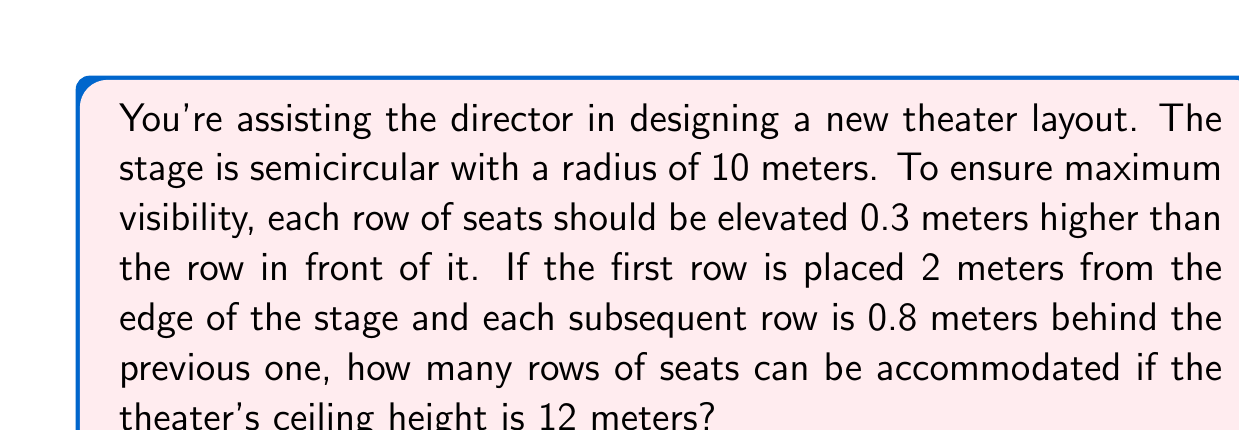Help me with this question. Let's approach this step-by-step:

1) First, we need to determine the height of the first row relative to the stage:
   Let's assume the stage is at ground level (0 meters).
   The first row will be at the same level as the stage.

2) Now, let's set up a formula for the height of each row:
   $h_n = 0.3(n-1)$, where $n$ is the row number (starting from 1)

3) We also need a formula for the distance of each row from the stage edge:
   $d_n = 2 + 0.8(n-1)$

4) The maximum number of rows will be reached when the height of a row equals or just exceeds the ceiling height (12 meters).

5) We can set up an inequality:
   $0.3(n-1) \leq 12$

6) Solving for n:
   $0.3n - 0.3 \leq 12$
   $0.3n \leq 12.3$
   $n \leq 41$

7) The largest integer value of n that satisfies this inequality is 41.

8) Let's verify:
   Height of the 41st row: $h_{41} = 0.3(41-1) = 12$ meters
   Distance of the 41st row: $d_{41} = 2 + 0.8(41-1) = 34$ meters

9) The 41st row exactly reaches the ceiling height, confirming our calculation.
Answer: 41 rows 